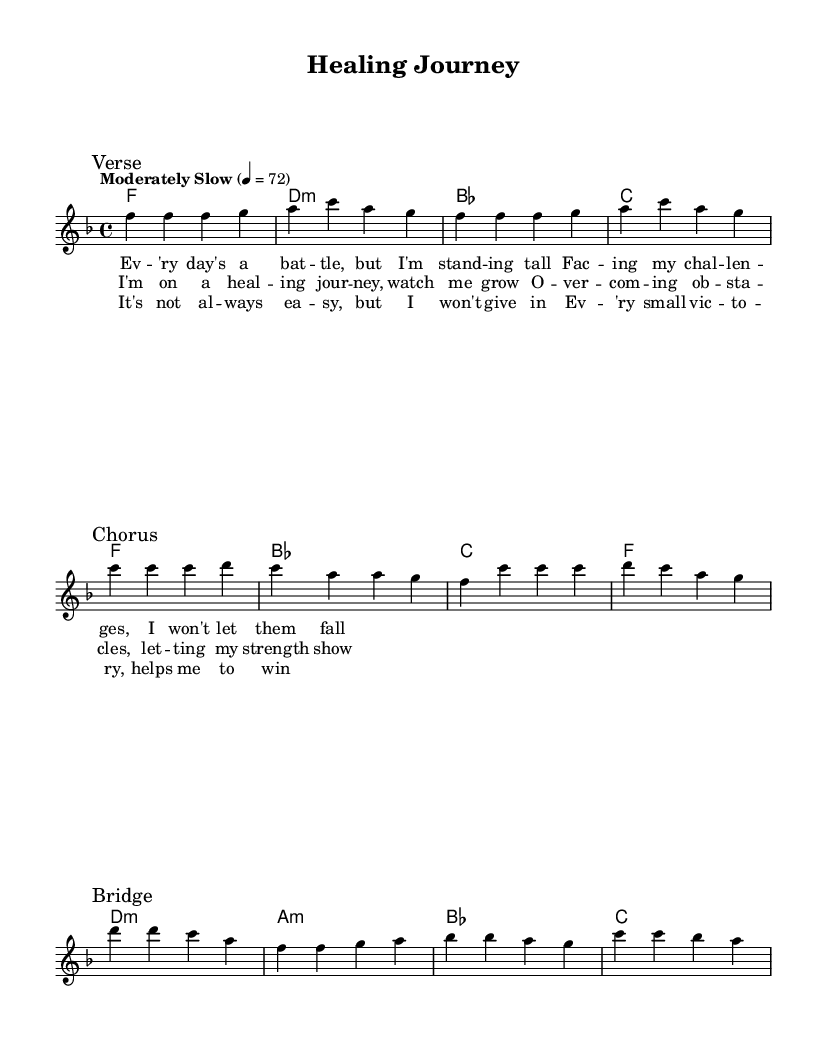What is the key signature of this music? The key signature is F major, which has one flat (B♭). This is determined by the presence of the flat in the key signature at the beginning of the staff.
Answer: F major What is the time signature of the music? The time signature is 4/4, which indicates that there are four beats in each measure and the quarter note gets one beat. This is shown at the beginning of the music where the time signature is notated as 4/4.
Answer: 4/4 What is the tempo marking for this piece? The tempo marking is "Moderately Slow" with a metronome marking of 72 beats per minute. This information is indicated at the beginning of the score with the specified tempo.
Answer: Moderately Slow How many measures are in the verse section? The verse section contains 4 measures, as counted from the music notation following the "Verse" mark. Each measure is a distinct grouping of notes based on the time signature.
Answer: 4 What is the lyrical theme of the chorus? The lyrical theme of the chorus is about a healing journey where strength is demonstrated in overcoming obstacles. This can be inferred from the repeated ideas in the lyrics of the chorus.
Answer: Healing journey Which section of the music contains a contrasting melody? The bridge section contains a contrasting melody. This is apparent as it introduces different melodic lines and lyrics compared to the verse and chorus.
Answer: Bridge 